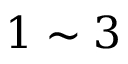Convert formula to latex. <formula><loc_0><loc_0><loc_500><loc_500>1 \sim 3</formula> 